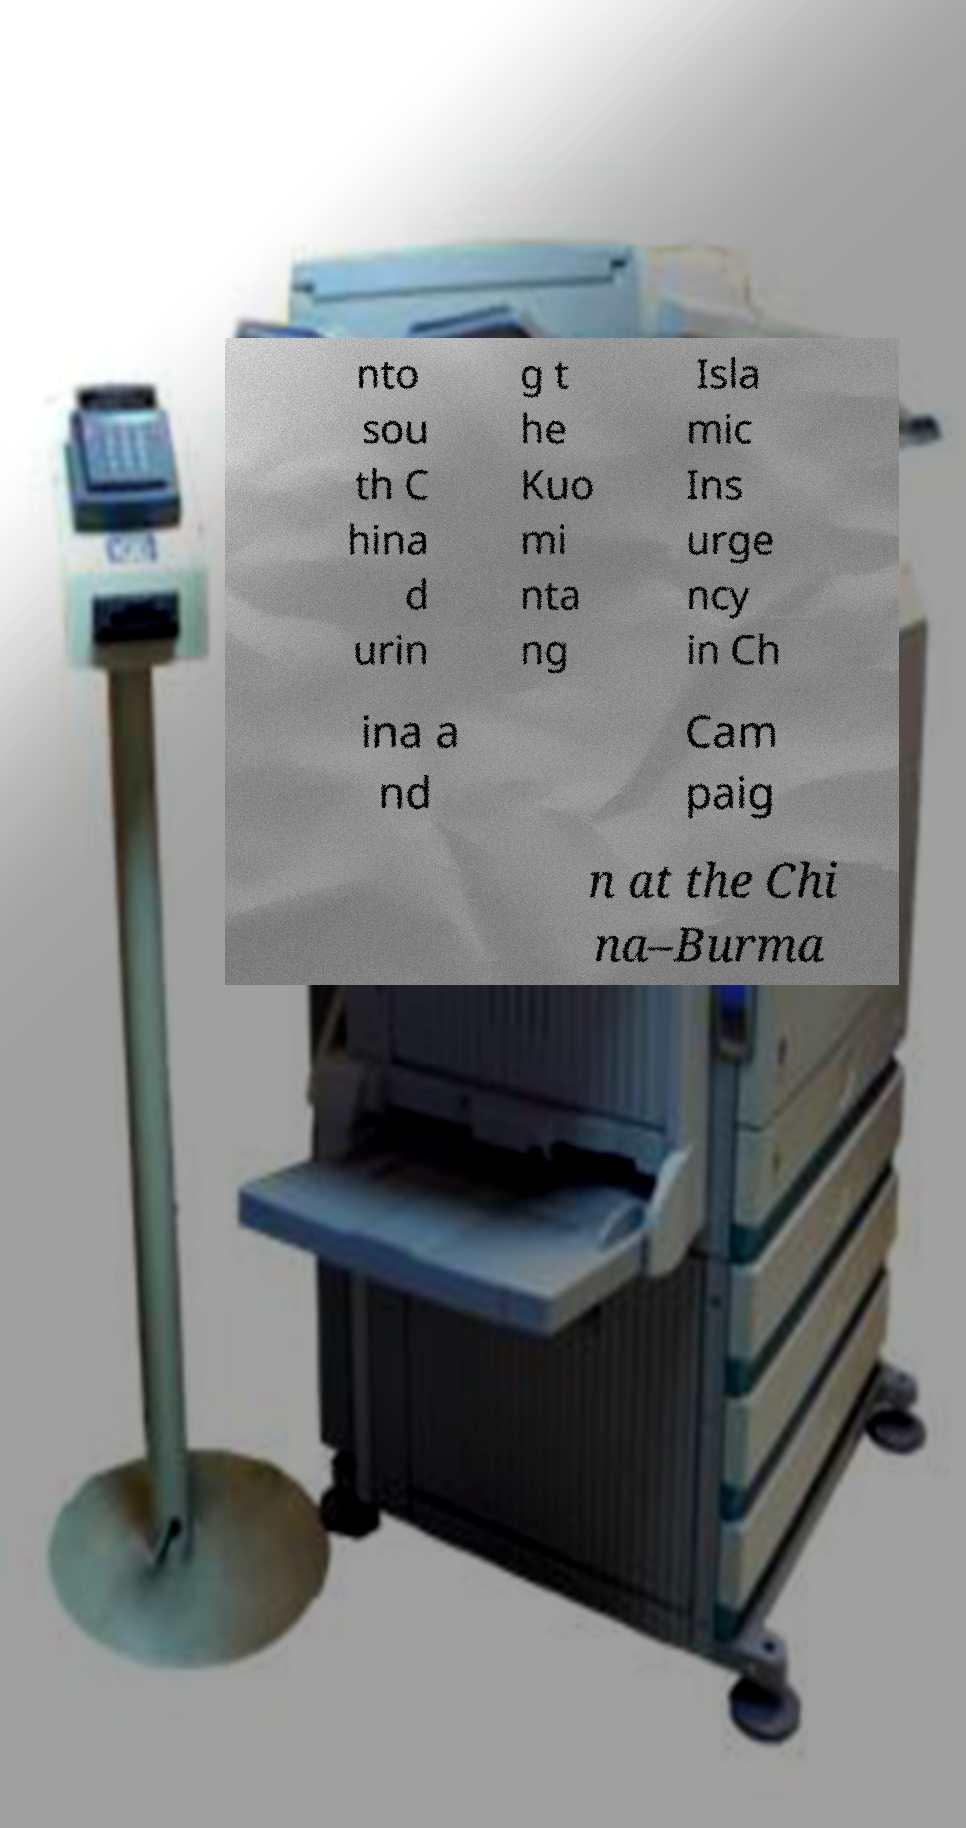Can you read and provide the text displayed in the image?This photo seems to have some interesting text. Can you extract and type it out for me? nto sou th C hina d urin g t he Kuo mi nta ng Isla mic Ins urge ncy in Ch ina a nd Cam paig n at the Chi na–Burma 